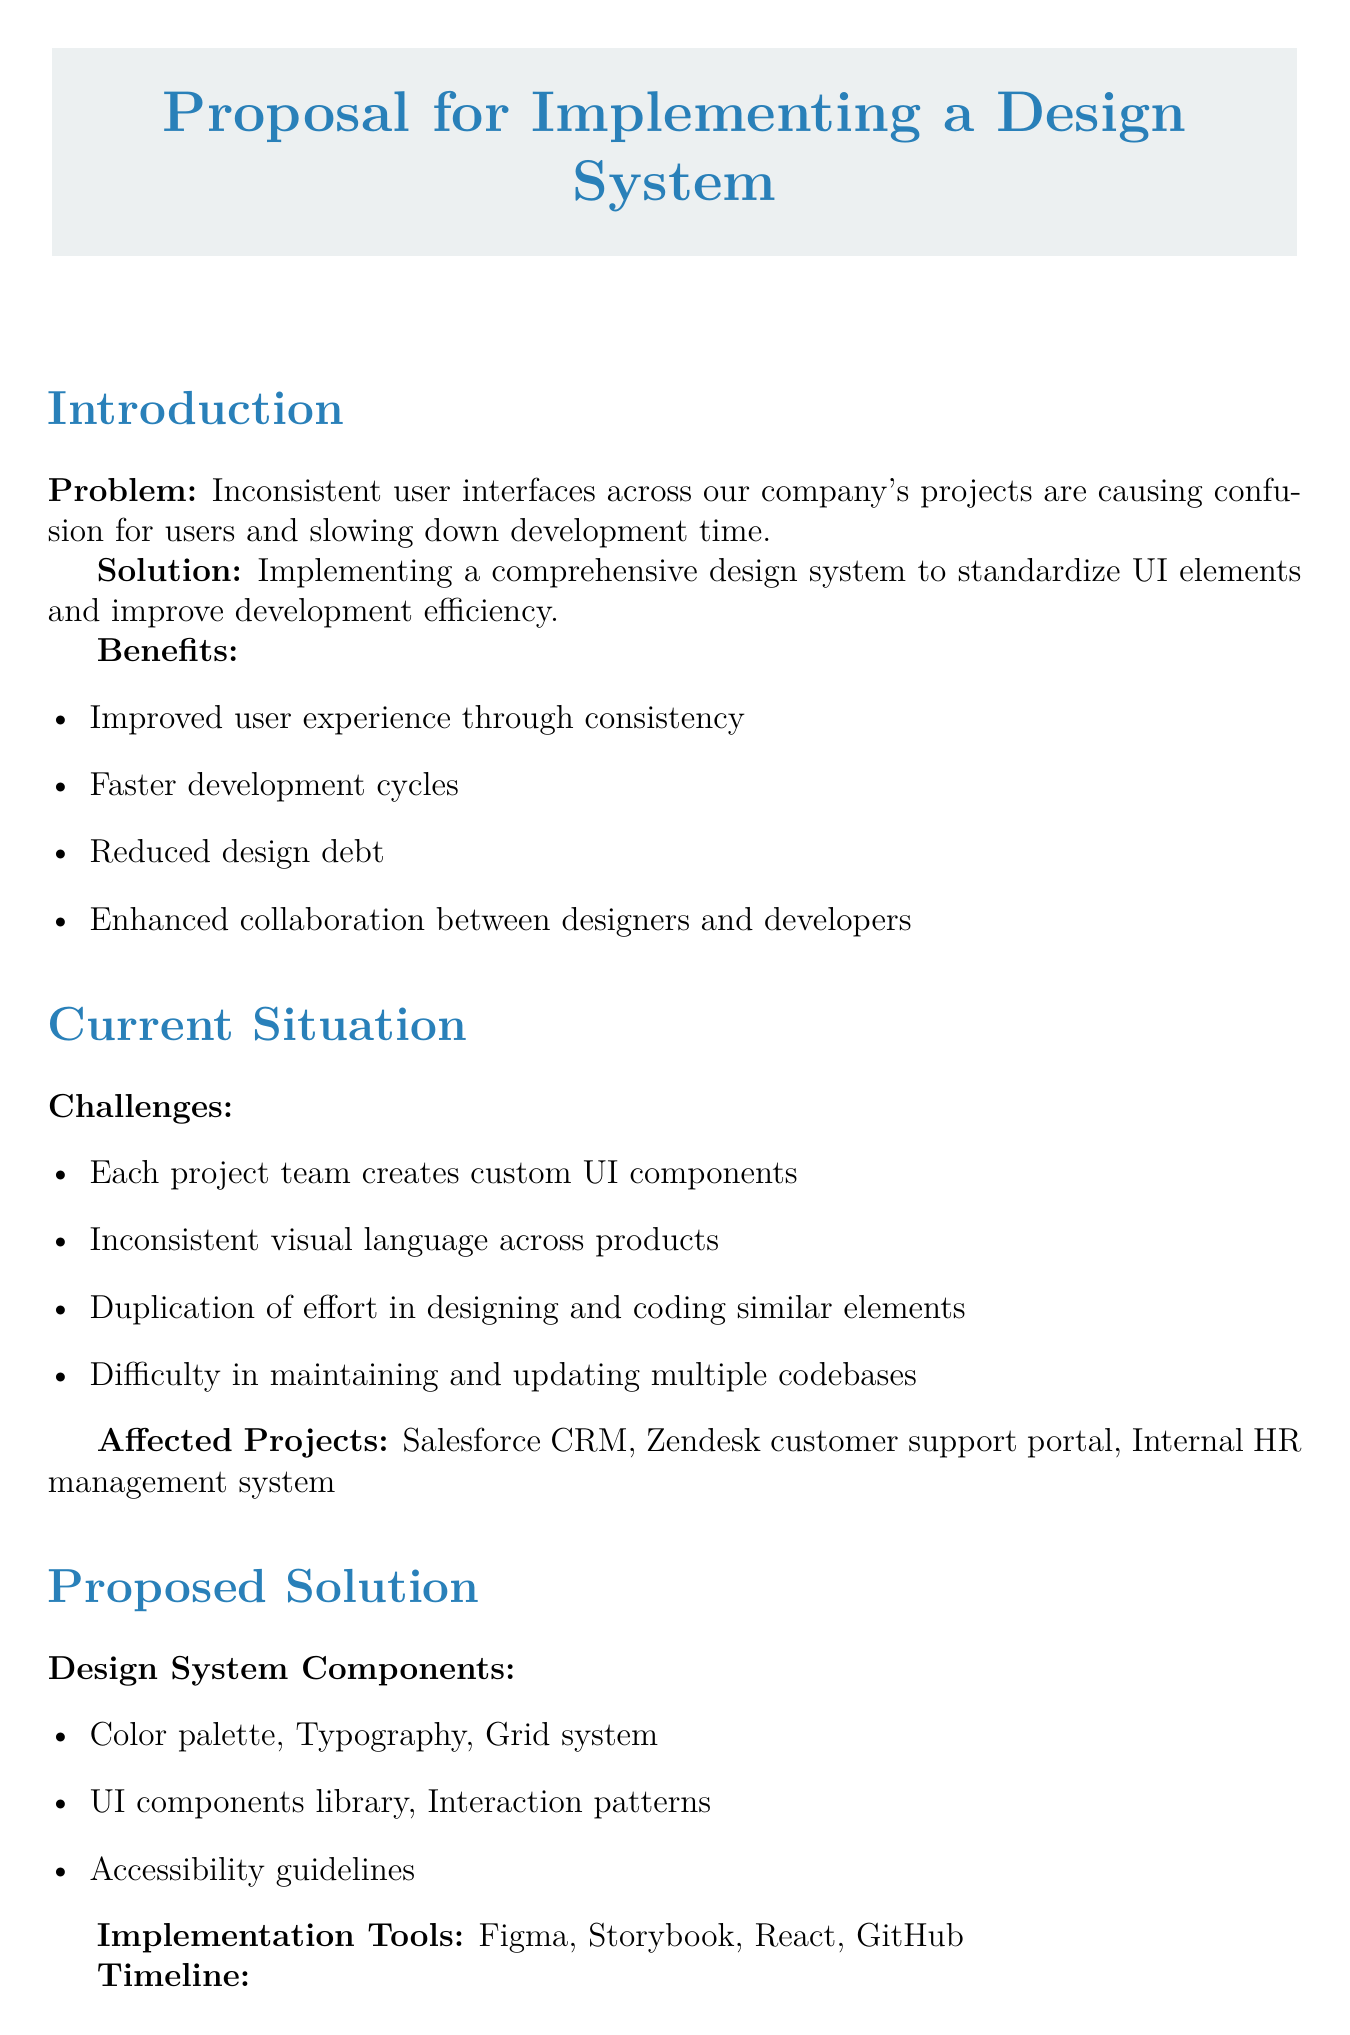What is the main problem identified in the memo? The memo states that inconsistent user interfaces across the company's projects are causing confusion for users and slowing down development time.
Answer: Inconsistent user interfaces What is the proposed design system budget? The document outlines the total budget required for the initial development and implementation of the design system.
Answer: $150,000 How many phases are proposed in the implementation timeline? The memo details a specific timeline consisting of several phases for implementing the design system.
Answer: 4 What tool is suggested for component documentation? The proposed solution includes specific tools for different tasks, including one for component documentation.
Answer: Storybook What is the expected short-term outcome for UI design time reduction? The document specifies a percentage reduction in time spent on UI design for new features as a short-term expected outcome.
Answer: 50% Who is required as a part of the design system team? The resource requirements section lists personnel roles needed for the design system implementation.
Answer: 1 Senior UX Designer What is the first step in the next steps section? The document outlines key actions needed to move forward with the proposal, starting with leadership approval.
Answer: Gain approval from leadership team What is one of the expected long-term outcomes related to maintenance costs? The memo provides insights into expected long-term outcomes, including one relating to cost reduction for UI-related issues.
Answer: Reduced maintenance costs What is one of the affected projects mentioned? The current situation section lists projects that are impacted by the inconsistent UI challenge.
Answer: Salesforce CRM 